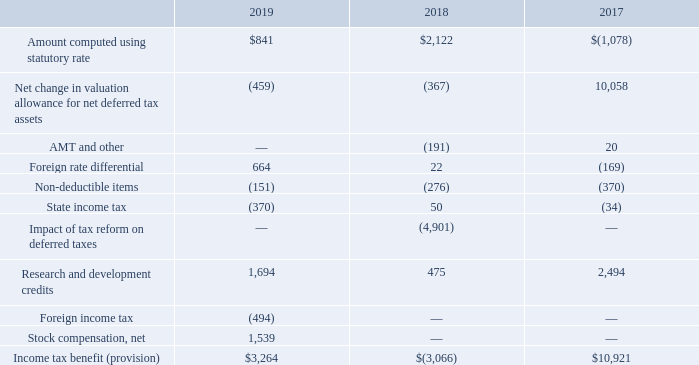Income Tax Provision Reconciliation
The difference between the income tax benefit (provision) and income taxes computed using the U.S. federal income tax rate was as follows for the years ended September 30, 2019, 2018, and 2017 (amounts shown in thousands):
What does the table show us? The difference between the income tax benefit (provision) and income taxes computed using the u.s. federal income tax rate. What are the income tax benefits (provision), for the fiscal years 2017, 2018, and 2019, respectively?
Answer scale should be: thousand. $10,921, $(3,066), $3,264. What are state income tax for the years 2018 and 2019, respectively?
Answer scale should be: thousand. 50, (370). Which year has the highest income tax benefit?  10,921>3,264>-3,066
Answer: 2017. What is the sum of amount computed using statutory rate and foreign rate differential in 2018 as a percentage of 2019? (2,122+22)/(841+664) 
Answer: 1.42. What is the percentage change in research and development credits from 2018 to 2019?
Answer scale should be: percent. (1,694-475)/475 
Answer: 256.63. 